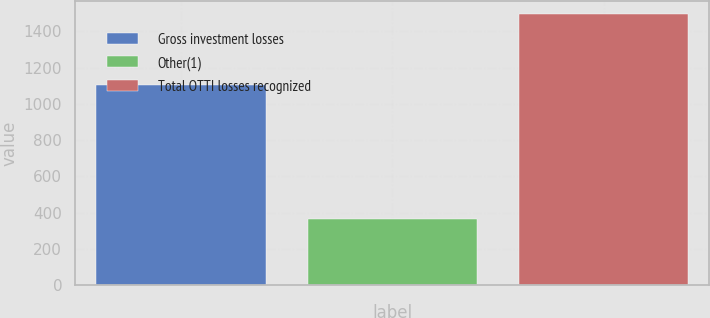<chart> <loc_0><loc_0><loc_500><loc_500><bar_chart><fcel>Gross investment losses<fcel>Other(1)<fcel>Total OTTI losses recognized<nl><fcel>1104<fcel>363<fcel>1493<nl></chart> 